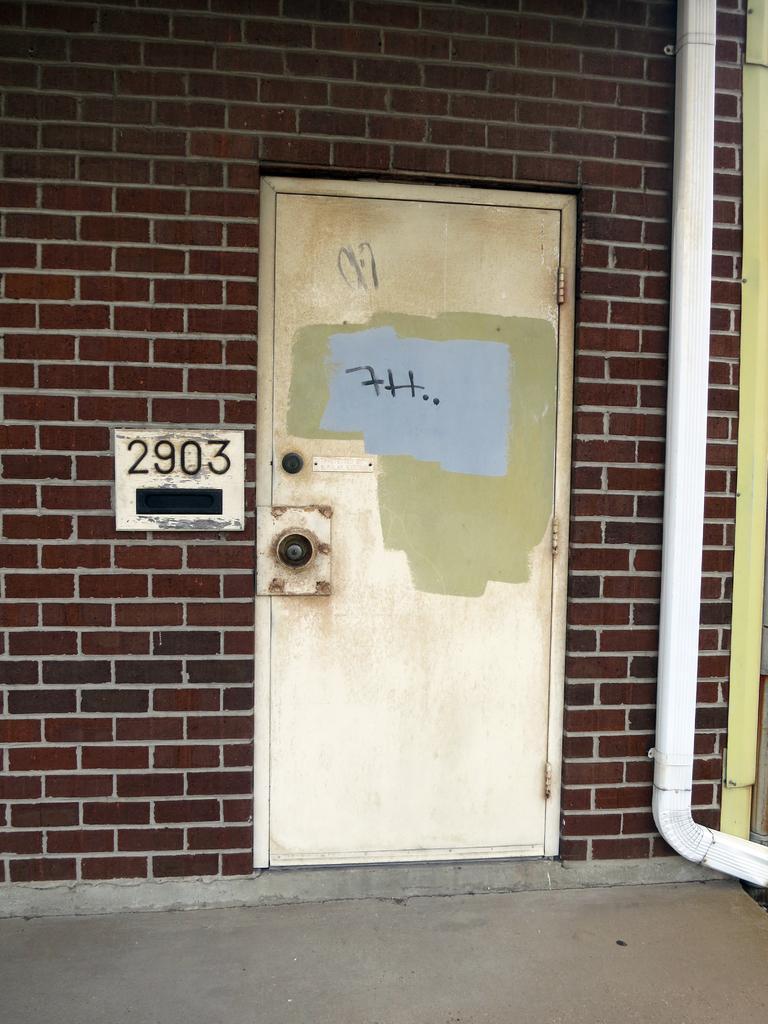How would you summarize this image in a sentence or two? In this image we can see a door. On the left side we can see board on a wall with some numbers on it. On the right side we can see a pipe. 